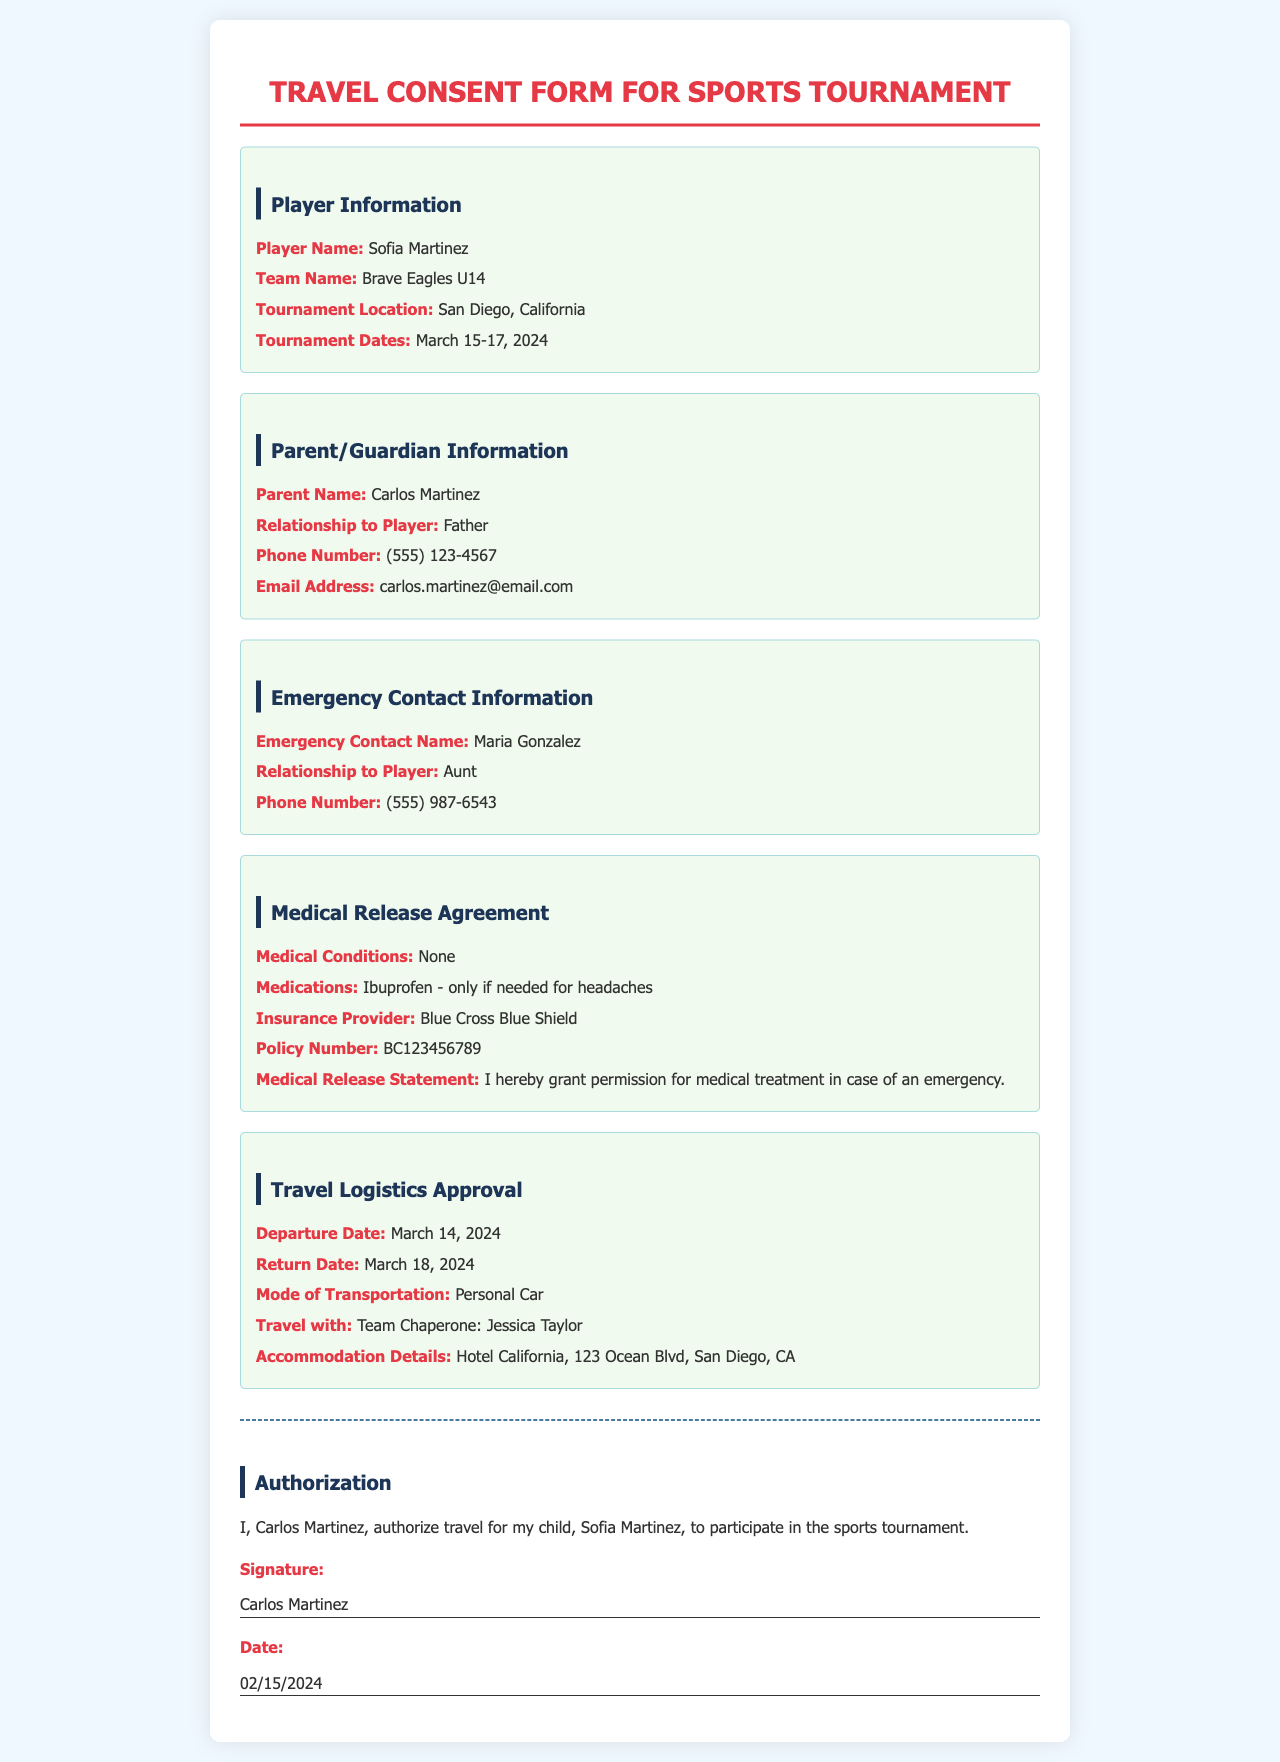What is the player's name? The player's name is clearly indicated in the document under Player Information.
Answer: Sofia Martinez What is the team name? The team name is specified directly beneath the player's name in the Player Information section.
Answer: Brave Eagles U14 What are the tournament dates? The tournament dates are mentioned in the Player Information section of the document.
Answer: March 15-17, 2024 Who is the emergency contact? The name of the emergency contact is provided in the Emergency Contact Information section.
Answer: Maria Gonzalez What is the mode of transportation? The mode of transportation is listed in the Travel Logistics Approval section of the document.
Answer: Personal Car What medical condition is noted for the player? The document specifies any medical conditions in the Medical Release Agreement section.
Answer: None Who will Sofia travel with? The document mentions the accompanying person in the Travel Logistics Approval section.
Answer: Team Chaperone: Jessica Taylor What hotel will the team stay at? The accommodation details are provided in the Travel Logistics Approval section of the document.
Answer: Hotel California What is the parent's phone number? The parent's phone number can be found in the Parent/Guardian Information section.
Answer: (555) 123-4567 What is the medical release statement? The medical release statement can be found listed in the Medical Release Agreement section.
Answer: I hereby grant permission for medical treatment in case of an emergency 